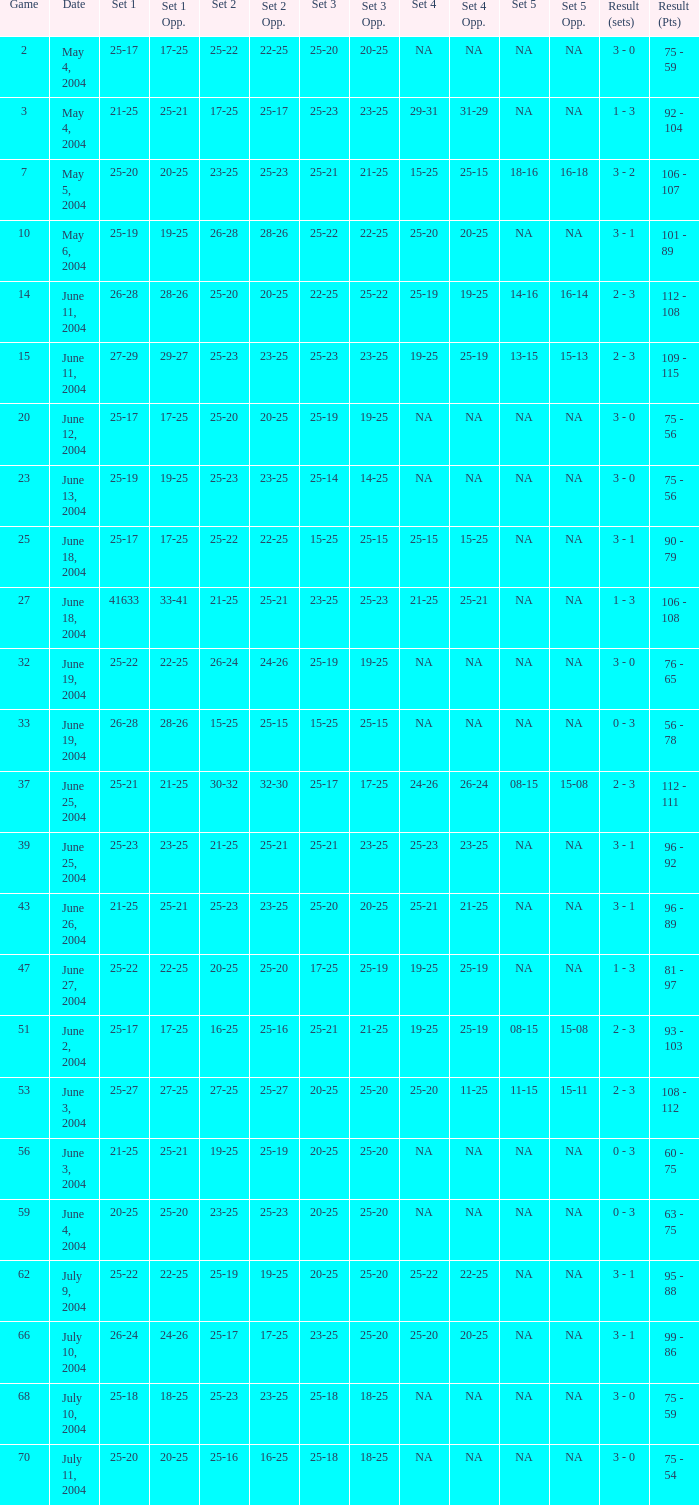What is the result of the game with a set 1 of 26-24? 99 - 86. Can you give me this table as a dict? {'header': ['Game', 'Date', 'Set 1', 'Set 1 Opp.', 'Set 2', 'Set 2 Opp.', 'Set 3', 'Set 3 Opp.', 'Set 4', 'Set 4 Opp.', 'Set 5', 'Set 5 Opp.', 'Result (sets)', 'Result (Pts)'], 'rows': [['2', 'May 4, 2004', '25-17', '17-25', '25-22', '22-25', '25-20', '20-25', 'NA', 'NA', 'NA', 'NA', '3 - 0', '75 - 59'], ['3', 'May 4, 2004', '21-25', '25-21', '17-25', '25-17', '25-23', '23-25', '29-31', '31-29', 'NA', 'NA', '1 - 3', '92 - 104'], ['7', 'May 5, 2004', '25-20', '20-25', '23-25', '25-23', '25-21', '21-25', '15-25', '25-15', '18-16', '16-18', '3 - 2', '106 - 107'], ['10', 'May 6, 2004', '25-19', '19-25', '26-28', '28-26', '25-22', '22-25', '25-20', '20-25', 'NA', 'NA', '3 - 1', '101 - 89'], ['14', 'June 11, 2004', '26-28', '28-26', '25-20', '20-25', '22-25', '25-22', '25-19', '19-25', '14-16', '16-14', '2 - 3', '112 - 108'], ['15', 'June 11, 2004', '27-29', '29-27', '25-23', '23-25', '25-23', '23-25', '19-25', '25-19', '13-15', '15-13', '2 - 3', '109 - 115'], ['20', 'June 12, 2004', '25-17', '17-25', '25-20', '20-25', '25-19', '19-25', 'NA', 'NA', 'NA', 'NA', '3 - 0', '75 - 56'], ['23', 'June 13, 2004', '25-19', '19-25', '25-23', '23-25', '25-14', '14-25', 'NA', 'NA', 'NA', 'NA', '3 - 0', '75 - 56'], ['25', 'June 18, 2004', '25-17', '17-25', '25-22', '22-25', '15-25', '25-15', '25-15', '15-25', 'NA', 'NA', '3 - 1', '90 - 79'], ['27', 'June 18, 2004', '41633', '33-41', '21-25', '25-21', '23-25', '25-23', '21-25', '25-21', 'NA', 'NA', '1 - 3', '106 - 108'], ['32', 'June 19, 2004', '25-22', '22-25', '26-24', '24-26', '25-19', '19-25', 'NA', 'NA', 'NA', 'NA', '3 - 0', '76 - 65'], ['33', 'June 19, 2004', '26-28', '28-26', '15-25', '25-15', '15-25', '25-15', 'NA', 'NA', 'NA', 'NA', '0 - 3', '56 - 78'], ['37', 'June 25, 2004', '25-21', '21-25', '30-32', '32-30', '25-17', '17-25', '24-26', '26-24', '08-15', '15-08', '2 - 3', '112 - 111'], ['39', 'June 25, 2004', '25-23', '23-25', '21-25', '25-21', '25-21', '23-25', '25-23', '23-25', 'NA', 'NA', '3 - 1', '96 - 92'], ['43', 'June 26, 2004', '21-25', '25-21', '25-23', '23-25', '25-20', '20-25', '25-21', '21-25', 'NA', 'NA', '3 - 1', '96 - 89'], ['47', 'June 27, 2004', '25-22', '22-25', '20-25', '25-20', '17-25', '25-19', '19-25', '25-19', 'NA', 'NA', '1 - 3', '81 - 97'], ['51', 'June 2, 2004', '25-17', '17-25', '16-25', '25-16', '25-21', '21-25', '19-25', '25-19', '08-15', '15-08', '2 - 3', '93 - 103'], ['53', 'June 3, 2004', '25-27', '27-25', '27-25', '25-27', '20-25', '25-20', '25-20', '11-25', '11-15', '15-11', '2 - 3', '108 - 112'], ['56', 'June 3, 2004', '21-25', '25-21', '19-25', '25-19', '20-25', '25-20', 'NA', 'NA', 'NA', 'NA', '0 - 3', '60 - 75'], ['59', 'June 4, 2004', '20-25', '25-20', '23-25', '25-23', '20-25', '25-20', 'NA', 'NA', 'NA', 'NA', '0 - 3', '63 - 75'], ['62', 'July 9, 2004', '25-22', '22-25', '25-19', '19-25', '20-25', '25-20', '25-22', '22-25', 'NA', 'NA', '3 - 1', '95 - 88'], ['66', 'July 10, 2004', '26-24', '24-26', '25-17', '17-25', '23-25', '25-20', '25-20', '20-25', 'NA', 'NA', '3 - 1', '99 - 86'], ['68', 'July 10, 2004', '25-18', '18-25', '25-23', '23-25', '25-18', '18-25', 'NA', 'NA', 'NA', 'NA', '3 - 0', '75 - 59'], ['70', 'July 11, 2004', '25-20', '20-25', '25-16', '16-25', '25-18', '18-25', 'NA', 'NA', 'NA', 'NA', '3 - 0', '75 - 54']]} 